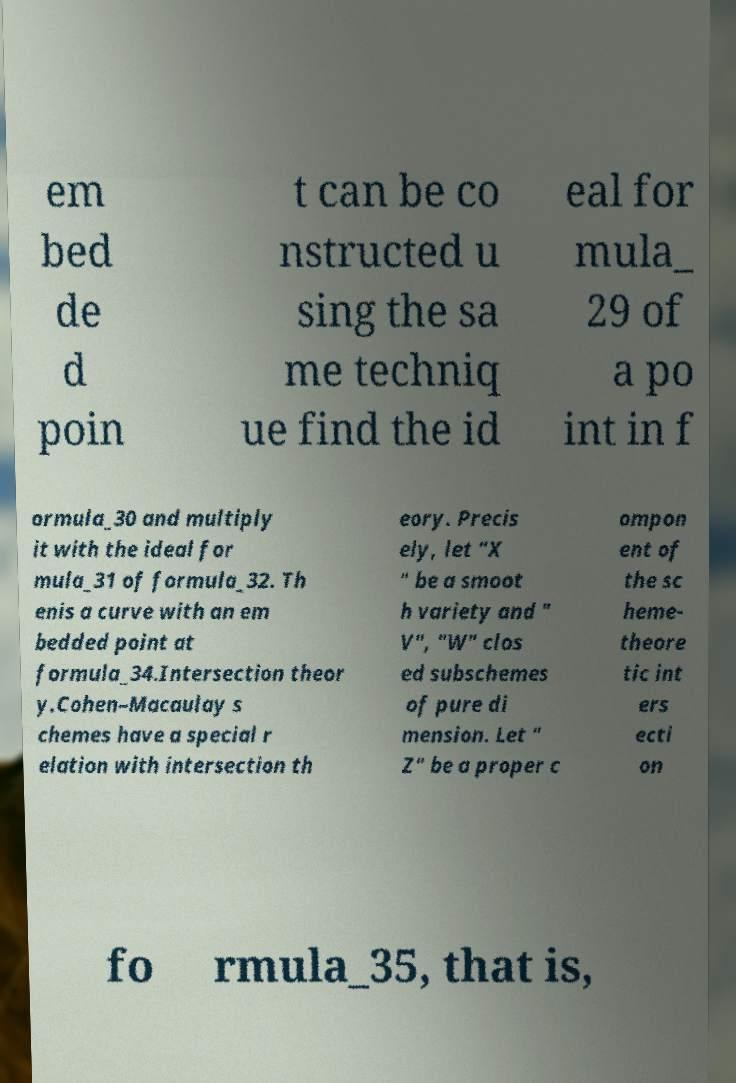Can you read and provide the text displayed in the image?This photo seems to have some interesting text. Can you extract and type it out for me? em bed de d poin t can be co nstructed u sing the sa me techniq ue find the id eal for mula_ 29 of a po int in f ormula_30 and multiply it with the ideal for mula_31 of formula_32. Th enis a curve with an em bedded point at formula_34.Intersection theor y.Cohen–Macaulay s chemes have a special r elation with intersection th eory. Precis ely, let "X " be a smoot h variety and " V", "W" clos ed subschemes of pure di mension. Let " Z" be a proper c ompon ent of the sc heme- theore tic int ers ecti on fo rmula_35, that is, 